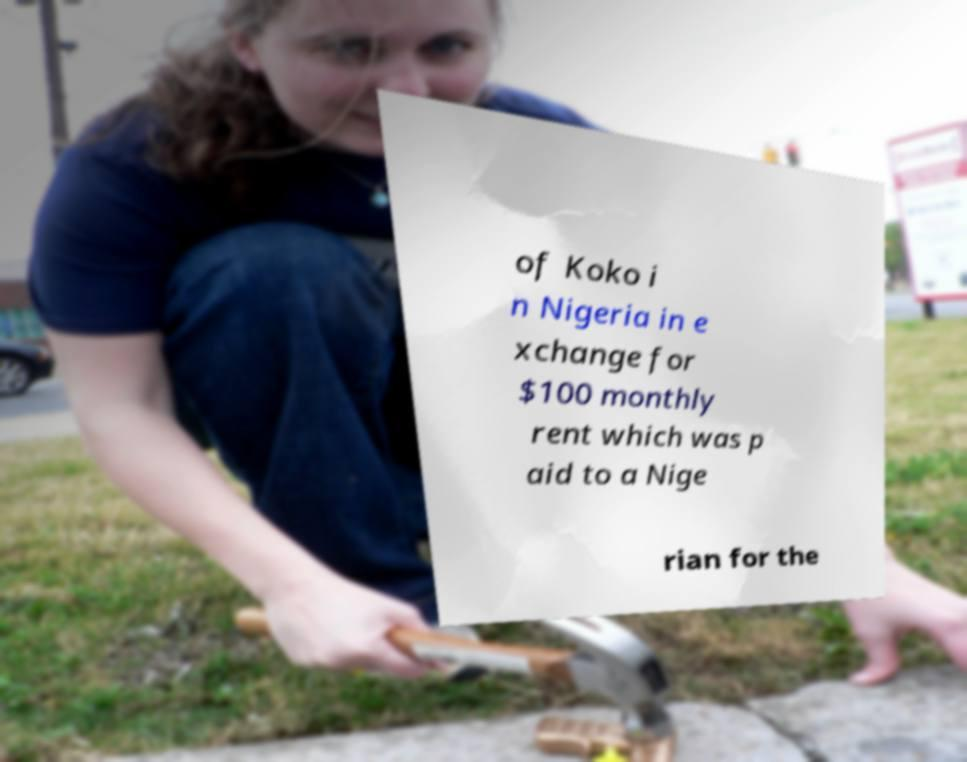Could you assist in decoding the text presented in this image and type it out clearly? of Koko i n Nigeria in e xchange for $100 monthly rent which was p aid to a Nige rian for the 